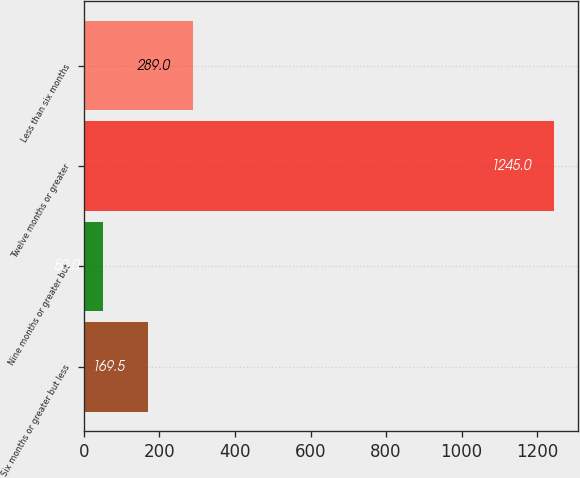Convert chart to OTSL. <chart><loc_0><loc_0><loc_500><loc_500><bar_chart><fcel>Six months or greater but less<fcel>Nine months or greater but<fcel>Twelve months or greater<fcel>Less than six months<nl><fcel>169.5<fcel>50<fcel>1245<fcel>289<nl></chart> 